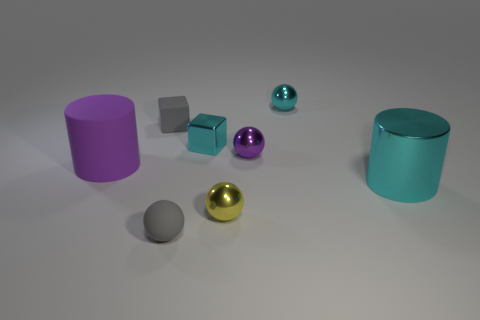How many shiny blocks are the same size as the gray rubber cube?
Your response must be concise. 1. Is the size of the gray ball the same as the purple cylinder?
Keep it short and to the point. No. There is a metal object that is left of the purple ball and behind the tiny purple metallic ball; what size is it?
Ensure brevity in your answer.  Small. Is the number of cyan objects that are behind the yellow metallic object greater than the number of cyan metallic objects right of the large cyan metallic cylinder?
Ensure brevity in your answer.  Yes. What is the color of the rubber thing that is the same shape as the big cyan shiny thing?
Provide a short and direct response. Purple. Is the color of the small matte object that is behind the yellow thing the same as the rubber ball?
Provide a short and direct response. Yes. How many big shiny things are there?
Offer a terse response. 1. Is the tiny yellow ball in front of the purple matte thing made of the same material as the cyan ball?
Provide a short and direct response. Yes. Is there anything else that has the same material as the small purple ball?
Give a very brief answer. Yes. There is a big object on the right side of the tiny gray matte object in front of the small gray block; what number of tiny purple spheres are in front of it?
Give a very brief answer. 0. 